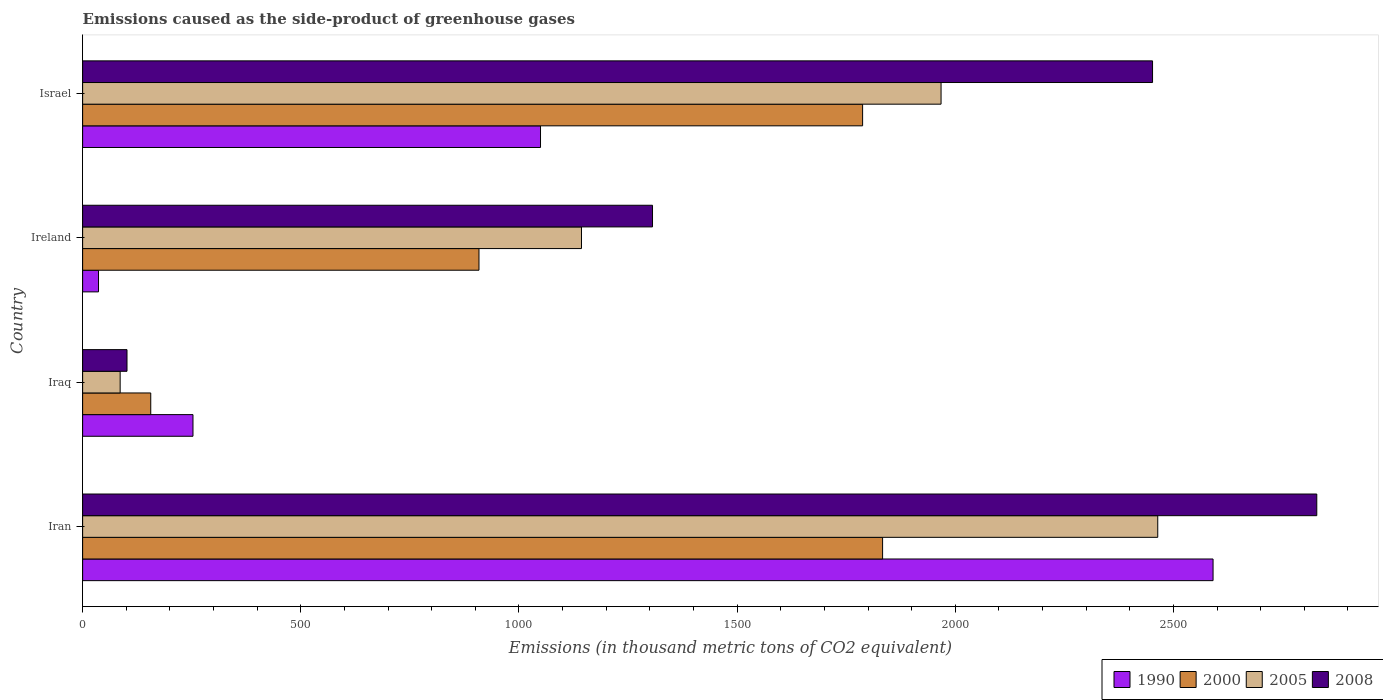How many groups of bars are there?
Your response must be concise. 4. How many bars are there on the 3rd tick from the top?
Make the answer very short. 4. How many bars are there on the 2nd tick from the bottom?
Your answer should be compact. 4. What is the label of the 2nd group of bars from the top?
Offer a very short reply. Ireland. In how many cases, is the number of bars for a given country not equal to the number of legend labels?
Provide a succinct answer. 0. Across all countries, what is the maximum emissions caused as the side-product of greenhouse gases in 1990?
Make the answer very short. 2590.8. Across all countries, what is the minimum emissions caused as the side-product of greenhouse gases in 2008?
Give a very brief answer. 101.7. In which country was the emissions caused as the side-product of greenhouse gases in 1990 maximum?
Offer a terse response. Iran. In which country was the emissions caused as the side-product of greenhouse gases in 1990 minimum?
Your response must be concise. Ireland. What is the total emissions caused as the side-product of greenhouse gases in 1990 in the graph?
Provide a succinct answer. 3929.5. What is the difference between the emissions caused as the side-product of greenhouse gases in 2000 in Iran and that in Israel?
Provide a short and direct response. 45.8. What is the difference between the emissions caused as the side-product of greenhouse gases in 1990 in Ireland and the emissions caused as the side-product of greenhouse gases in 2000 in Israel?
Ensure brevity in your answer.  -1751.2. What is the average emissions caused as the side-product of greenhouse gases in 1990 per country?
Your response must be concise. 982.38. What is the difference between the emissions caused as the side-product of greenhouse gases in 2005 and emissions caused as the side-product of greenhouse gases in 1990 in Iran?
Your answer should be very brief. -126.8. What is the ratio of the emissions caused as the side-product of greenhouse gases in 2000 in Iran to that in Israel?
Your answer should be compact. 1.03. Is the emissions caused as the side-product of greenhouse gases in 2008 in Iran less than that in Ireland?
Provide a succinct answer. No. What is the difference between the highest and the second highest emissions caused as the side-product of greenhouse gases in 1990?
Offer a terse response. 1541.4. What is the difference between the highest and the lowest emissions caused as the side-product of greenhouse gases in 2008?
Offer a very short reply. 2726.8. What does the 4th bar from the top in Iraq represents?
Ensure brevity in your answer.  1990. What does the 2nd bar from the bottom in Ireland represents?
Ensure brevity in your answer.  2000. Is it the case that in every country, the sum of the emissions caused as the side-product of greenhouse gases in 2005 and emissions caused as the side-product of greenhouse gases in 2000 is greater than the emissions caused as the side-product of greenhouse gases in 1990?
Give a very brief answer. No. Are all the bars in the graph horizontal?
Give a very brief answer. Yes. What is the difference between two consecutive major ticks on the X-axis?
Give a very brief answer. 500. Are the values on the major ticks of X-axis written in scientific E-notation?
Offer a very short reply. No. How many legend labels are there?
Offer a very short reply. 4. How are the legend labels stacked?
Provide a succinct answer. Horizontal. What is the title of the graph?
Keep it short and to the point. Emissions caused as the side-product of greenhouse gases. What is the label or title of the X-axis?
Provide a succinct answer. Emissions (in thousand metric tons of CO2 equivalent). What is the Emissions (in thousand metric tons of CO2 equivalent) in 1990 in Iran?
Make the answer very short. 2590.8. What is the Emissions (in thousand metric tons of CO2 equivalent) in 2000 in Iran?
Ensure brevity in your answer.  1833.4. What is the Emissions (in thousand metric tons of CO2 equivalent) in 2005 in Iran?
Provide a short and direct response. 2464. What is the Emissions (in thousand metric tons of CO2 equivalent) of 2008 in Iran?
Provide a succinct answer. 2828.5. What is the Emissions (in thousand metric tons of CO2 equivalent) of 1990 in Iraq?
Your answer should be compact. 252.9. What is the Emissions (in thousand metric tons of CO2 equivalent) in 2000 in Iraq?
Keep it short and to the point. 156.1. What is the Emissions (in thousand metric tons of CO2 equivalent) in 2008 in Iraq?
Ensure brevity in your answer.  101.7. What is the Emissions (in thousand metric tons of CO2 equivalent) of 1990 in Ireland?
Your response must be concise. 36.4. What is the Emissions (in thousand metric tons of CO2 equivalent) of 2000 in Ireland?
Ensure brevity in your answer.  908.4. What is the Emissions (in thousand metric tons of CO2 equivalent) in 2005 in Ireland?
Provide a succinct answer. 1143.3. What is the Emissions (in thousand metric tons of CO2 equivalent) in 2008 in Ireland?
Offer a very short reply. 1306.1. What is the Emissions (in thousand metric tons of CO2 equivalent) of 1990 in Israel?
Offer a terse response. 1049.4. What is the Emissions (in thousand metric tons of CO2 equivalent) of 2000 in Israel?
Offer a terse response. 1787.6. What is the Emissions (in thousand metric tons of CO2 equivalent) in 2005 in Israel?
Provide a succinct answer. 1967.4. What is the Emissions (in thousand metric tons of CO2 equivalent) in 2008 in Israel?
Provide a succinct answer. 2452.1. Across all countries, what is the maximum Emissions (in thousand metric tons of CO2 equivalent) of 1990?
Offer a very short reply. 2590.8. Across all countries, what is the maximum Emissions (in thousand metric tons of CO2 equivalent) in 2000?
Give a very brief answer. 1833.4. Across all countries, what is the maximum Emissions (in thousand metric tons of CO2 equivalent) of 2005?
Provide a short and direct response. 2464. Across all countries, what is the maximum Emissions (in thousand metric tons of CO2 equivalent) in 2008?
Ensure brevity in your answer.  2828.5. Across all countries, what is the minimum Emissions (in thousand metric tons of CO2 equivalent) in 1990?
Give a very brief answer. 36.4. Across all countries, what is the minimum Emissions (in thousand metric tons of CO2 equivalent) of 2000?
Offer a terse response. 156.1. Across all countries, what is the minimum Emissions (in thousand metric tons of CO2 equivalent) in 2008?
Ensure brevity in your answer.  101.7. What is the total Emissions (in thousand metric tons of CO2 equivalent) of 1990 in the graph?
Offer a very short reply. 3929.5. What is the total Emissions (in thousand metric tons of CO2 equivalent) of 2000 in the graph?
Provide a short and direct response. 4685.5. What is the total Emissions (in thousand metric tons of CO2 equivalent) of 2005 in the graph?
Offer a terse response. 5660.7. What is the total Emissions (in thousand metric tons of CO2 equivalent) of 2008 in the graph?
Give a very brief answer. 6688.4. What is the difference between the Emissions (in thousand metric tons of CO2 equivalent) of 1990 in Iran and that in Iraq?
Offer a very short reply. 2337.9. What is the difference between the Emissions (in thousand metric tons of CO2 equivalent) of 2000 in Iran and that in Iraq?
Keep it short and to the point. 1677.3. What is the difference between the Emissions (in thousand metric tons of CO2 equivalent) in 2005 in Iran and that in Iraq?
Your answer should be compact. 2378. What is the difference between the Emissions (in thousand metric tons of CO2 equivalent) in 2008 in Iran and that in Iraq?
Offer a very short reply. 2726.8. What is the difference between the Emissions (in thousand metric tons of CO2 equivalent) of 1990 in Iran and that in Ireland?
Offer a terse response. 2554.4. What is the difference between the Emissions (in thousand metric tons of CO2 equivalent) of 2000 in Iran and that in Ireland?
Give a very brief answer. 925. What is the difference between the Emissions (in thousand metric tons of CO2 equivalent) of 2005 in Iran and that in Ireland?
Make the answer very short. 1320.7. What is the difference between the Emissions (in thousand metric tons of CO2 equivalent) of 2008 in Iran and that in Ireland?
Your answer should be very brief. 1522.4. What is the difference between the Emissions (in thousand metric tons of CO2 equivalent) in 1990 in Iran and that in Israel?
Keep it short and to the point. 1541.4. What is the difference between the Emissions (in thousand metric tons of CO2 equivalent) of 2000 in Iran and that in Israel?
Make the answer very short. 45.8. What is the difference between the Emissions (in thousand metric tons of CO2 equivalent) of 2005 in Iran and that in Israel?
Provide a short and direct response. 496.6. What is the difference between the Emissions (in thousand metric tons of CO2 equivalent) of 2008 in Iran and that in Israel?
Ensure brevity in your answer.  376.4. What is the difference between the Emissions (in thousand metric tons of CO2 equivalent) in 1990 in Iraq and that in Ireland?
Your answer should be very brief. 216.5. What is the difference between the Emissions (in thousand metric tons of CO2 equivalent) in 2000 in Iraq and that in Ireland?
Your answer should be compact. -752.3. What is the difference between the Emissions (in thousand metric tons of CO2 equivalent) in 2005 in Iraq and that in Ireland?
Offer a terse response. -1057.3. What is the difference between the Emissions (in thousand metric tons of CO2 equivalent) in 2008 in Iraq and that in Ireland?
Offer a very short reply. -1204.4. What is the difference between the Emissions (in thousand metric tons of CO2 equivalent) in 1990 in Iraq and that in Israel?
Keep it short and to the point. -796.5. What is the difference between the Emissions (in thousand metric tons of CO2 equivalent) in 2000 in Iraq and that in Israel?
Keep it short and to the point. -1631.5. What is the difference between the Emissions (in thousand metric tons of CO2 equivalent) in 2005 in Iraq and that in Israel?
Your answer should be compact. -1881.4. What is the difference between the Emissions (in thousand metric tons of CO2 equivalent) of 2008 in Iraq and that in Israel?
Ensure brevity in your answer.  -2350.4. What is the difference between the Emissions (in thousand metric tons of CO2 equivalent) of 1990 in Ireland and that in Israel?
Give a very brief answer. -1013. What is the difference between the Emissions (in thousand metric tons of CO2 equivalent) in 2000 in Ireland and that in Israel?
Your answer should be very brief. -879.2. What is the difference between the Emissions (in thousand metric tons of CO2 equivalent) in 2005 in Ireland and that in Israel?
Make the answer very short. -824.1. What is the difference between the Emissions (in thousand metric tons of CO2 equivalent) in 2008 in Ireland and that in Israel?
Give a very brief answer. -1146. What is the difference between the Emissions (in thousand metric tons of CO2 equivalent) in 1990 in Iran and the Emissions (in thousand metric tons of CO2 equivalent) in 2000 in Iraq?
Offer a very short reply. 2434.7. What is the difference between the Emissions (in thousand metric tons of CO2 equivalent) in 1990 in Iran and the Emissions (in thousand metric tons of CO2 equivalent) in 2005 in Iraq?
Provide a short and direct response. 2504.8. What is the difference between the Emissions (in thousand metric tons of CO2 equivalent) in 1990 in Iran and the Emissions (in thousand metric tons of CO2 equivalent) in 2008 in Iraq?
Your response must be concise. 2489.1. What is the difference between the Emissions (in thousand metric tons of CO2 equivalent) in 2000 in Iran and the Emissions (in thousand metric tons of CO2 equivalent) in 2005 in Iraq?
Keep it short and to the point. 1747.4. What is the difference between the Emissions (in thousand metric tons of CO2 equivalent) in 2000 in Iran and the Emissions (in thousand metric tons of CO2 equivalent) in 2008 in Iraq?
Provide a short and direct response. 1731.7. What is the difference between the Emissions (in thousand metric tons of CO2 equivalent) of 2005 in Iran and the Emissions (in thousand metric tons of CO2 equivalent) of 2008 in Iraq?
Offer a terse response. 2362.3. What is the difference between the Emissions (in thousand metric tons of CO2 equivalent) in 1990 in Iran and the Emissions (in thousand metric tons of CO2 equivalent) in 2000 in Ireland?
Keep it short and to the point. 1682.4. What is the difference between the Emissions (in thousand metric tons of CO2 equivalent) of 1990 in Iran and the Emissions (in thousand metric tons of CO2 equivalent) of 2005 in Ireland?
Offer a terse response. 1447.5. What is the difference between the Emissions (in thousand metric tons of CO2 equivalent) of 1990 in Iran and the Emissions (in thousand metric tons of CO2 equivalent) of 2008 in Ireland?
Provide a succinct answer. 1284.7. What is the difference between the Emissions (in thousand metric tons of CO2 equivalent) in 2000 in Iran and the Emissions (in thousand metric tons of CO2 equivalent) in 2005 in Ireland?
Make the answer very short. 690.1. What is the difference between the Emissions (in thousand metric tons of CO2 equivalent) in 2000 in Iran and the Emissions (in thousand metric tons of CO2 equivalent) in 2008 in Ireland?
Provide a short and direct response. 527.3. What is the difference between the Emissions (in thousand metric tons of CO2 equivalent) of 2005 in Iran and the Emissions (in thousand metric tons of CO2 equivalent) of 2008 in Ireland?
Your answer should be very brief. 1157.9. What is the difference between the Emissions (in thousand metric tons of CO2 equivalent) in 1990 in Iran and the Emissions (in thousand metric tons of CO2 equivalent) in 2000 in Israel?
Your answer should be compact. 803.2. What is the difference between the Emissions (in thousand metric tons of CO2 equivalent) in 1990 in Iran and the Emissions (in thousand metric tons of CO2 equivalent) in 2005 in Israel?
Your answer should be very brief. 623.4. What is the difference between the Emissions (in thousand metric tons of CO2 equivalent) in 1990 in Iran and the Emissions (in thousand metric tons of CO2 equivalent) in 2008 in Israel?
Ensure brevity in your answer.  138.7. What is the difference between the Emissions (in thousand metric tons of CO2 equivalent) of 2000 in Iran and the Emissions (in thousand metric tons of CO2 equivalent) of 2005 in Israel?
Offer a very short reply. -134. What is the difference between the Emissions (in thousand metric tons of CO2 equivalent) in 2000 in Iran and the Emissions (in thousand metric tons of CO2 equivalent) in 2008 in Israel?
Provide a short and direct response. -618.7. What is the difference between the Emissions (in thousand metric tons of CO2 equivalent) of 2005 in Iran and the Emissions (in thousand metric tons of CO2 equivalent) of 2008 in Israel?
Offer a terse response. 11.9. What is the difference between the Emissions (in thousand metric tons of CO2 equivalent) in 1990 in Iraq and the Emissions (in thousand metric tons of CO2 equivalent) in 2000 in Ireland?
Give a very brief answer. -655.5. What is the difference between the Emissions (in thousand metric tons of CO2 equivalent) in 1990 in Iraq and the Emissions (in thousand metric tons of CO2 equivalent) in 2005 in Ireland?
Your answer should be very brief. -890.4. What is the difference between the Emissions (in thousand metric tons of CO2 equivalent) of 1990 in Iraq and the Emissions (in thousand metric tons of CO2 equivalent) of 2008 in Ireland?
Offer a terse response. -1053.2. What is the difference between the Emissions (in thousand metric tons of CO2 equivalent) of 2000 in Iraq and the Emissions (in thousand metric tons of CO2 equivalent) of 2005 in Ireland?
Keep it short and to the point. -987.2. What is the difference between the Emissions (in thousand metric tons of CO2 equivalent) in 2000 in Iraq and the Emissions (in thousand metric tons of CO2 equivalent) in 2008 in Ireland?
Your answer should be very brief. -1150. What is the difference between the Emissions (in thousand metric tons of CO2 equivalent) in 2005 in Iraq and the Emissions (in thousand metric tons of CO2 equivalent) in 2008 in Ireland?
Make the answer very short. -1220.1. What is the difference between the Emissions (in thousand metric tons of CO2 equivalent) in 1990 in Iraq and the Emissions (in thousand metric tons of CO2 equivalent) in 2000 in Israel?
Make the answer very short. -1534.7. What is the difference between the Emissions (in thousand metric tons of CO2 equivalent) of 1990 in Iraq and the Emissions (in thousand metric tons of CO2 equivalent) of 2005 in Israel?
Provide a short and direct response. -1714.5. What is the difference between the Emissions (in thousand metric tons of CO2 equivalent) of 1990 in Iraq and the Emissions (in thousand metric tons of CO2 equivalent) of 2008 in Israel?
Offer a terse response. -2199.2. What is the difference between the Emissions (in thousand metric tons of CO2 equivalent) of 2000 in Iraq and the Emissions (in thousand metric tons of CO2 equivalent) of 2005 in Israel?
Provide a short and direct response. -1811.3. What is the difference between the Emissions (in thousand metric tons of CO2 equivalent) of 2000 in Iraq and the Emissions (in thousand metric tons of CO2 equivalent) of 2008 in Israel?
Make the answer very short. -2296. What is the difference between the Emissions (in thousand metric tons of CO2 equivalent) of 2005 in Iraq and the Emissions (in thousand metric tons of CO2 equivalent) of 2008 in Israel?
Give a very brief answer. -2366.1. What is the difference between the Emissions (in thousand metric tons of CO2 equivalent) in 1990 in Ireland and the Emissions (in thousand metric tons of CO2 equivalent) in 2000 in Israel?
Ensure brevity in your answer.  -1751.2. What is the difference between the Emissions (in thousand metric tons of CO2 equivalent) of 1990 in Ireland and the Emissions (in thousand metric tons of CO2 equivalent) of 2005 in Israel?
Your answer should be very brief. -1931. What is the difference between the Emissions (in thousand metric tons of CO2 equivalent) of 1990 in Ireland and the Emissions (in thousand metric tons of CO2 equivalent) of 2008 in Israel?
Your answer should be compact. -2415.7. What is the difference between the Emissions (in thousand metric tons of CO2 equivalent) of 2000 in Ireland and the Emissions (in thousand metric tons of CO2 equivalent) of 2005 in Israel?
Offer a very short reply. -1059. What is the difference between the Emissions (in thousand metric tons of CO2 equivalent) of 2000 in Ireland and the Emissions (in thousand metric tons of CO2 equivalent) of 2008 in Israel?
Ensure brevity in your answer.  -1543.7. What is the difference between the Emissions (in thousand metric tons of CO2 equivalent) in 2005 in Ireland and the Emissions (in thousand metric tons of CO2 equivalent) in 2008 in Israel?
Make the answer very short. -1308.8. What is the average Emissions (in thousand metric tons of CO2 equivalent) of 1990 per country?
Offer a terse response. 982.38. What is the average Emissions (in thousand metric tons of CO2 equivalent) in 2000 per country?
Your response must be concise. 1171.38. What is the average Emissions (in thousand metric tons of CO2 equivalent) in 2005 per country?
Ensure brevity in your answer.  1415.17. What is the average Emissions (in thousand metric tons of CO2 equivalent) of 2008 per country?
Give a very brief answer. 1672.1. What is the difference between the Emissions (in thousand metric tons of CO2 equivalent) in 1990 and Emissions (in thousand metric tons of CO2 equivalent) in 2000 in Iran?
Provide a short and direct response. 757.4. What is the difference between the Emissions (in thousand metric tons of CO2 equivalent) in 1990 and Emissions (in thousand metric tons of CO2 equivalent) in 2005 in Iran?
Give a very brief answer. 126.8. What is the difference between the Emissions (in thousand metric tons of CO2 equivalent) in 1990 and Emissions (in thousand metric tons of CO2 equivalent) in 2008 in Iran?
Offer a very short reply. -237.7. What is the difference between the Emissions (in thousand metric tons of CO2 equivalent) in 2000 and Emissions (in thousand metric tons of CO2 equivalent) in 2005 in Iran?
Your answer should be compact. -630.6. What is the difference between the Emissions (in thousand metric tons of CO2 equivalent) in 2000 and Emissions (in thousand metric tons of CO2 equivalent) in 2008 in Iran?
Offer a terse response. -995.1. What is the difference between the Emissions (in thousand metric tons of CO2 equivalent) of 2005 and Emissions (in thousand metric tons of CO2 equivalent) of 2008 in Iran?
Offer a very short reply. -364.5. What is the difference between the Emissions (in thousand metric tons of CO2 equivalent) in 1990 and Emissions (in thousand metric tons of CO2 equivalent) in 2000 in Iraq?
Your response must be concise. 96.8. What is the difference between the Emissions (in thousand metric tons of CO2 equivalent) of 1990 and Emissions (in thousand metric tons of CO2 equivalent) of 2005 in Iraq?
Your answer should be very brief. 166.9. What is the difference between the Emissions (in thousand metric tons of CO2 equivalent) of 1990 and Emissions (in thousand metric tons of CO2 equivalent) of 2008 in Iraq?
Provide a succinct answer. 151.2. What is the difference between the Emissions (in thousand metric tons of CO2 equivalent) of 2000 and Emissions (in thousand metric tons of CO2 equivalent) of 2005 in Iraq?
Your answer should be very brief. 70.1. What is the difference between the Emissions (in thousand metric tons of CO2 equivalent) of 2000 and Emissions (in thousand metric tons of CO2 equivalent) of 2008 in Iraq?
Offer a very short reply. 54.4. What is the difference between the Emissions (in thousand metric tons of CO2 equivalent) of 2005 and Emissions (in thousand metric tons of CO2 equivalent) of 2008 in Iraq?
Give a very brief answer. -15.7. What is the difference between the Emissions (in thousand metric tons of CO2 equivalent) of 1990 and Emissions (in thousand metric tons of CO2 equivalent) of 2000 in Ireland?
Offer a terse response. -872. What is the difference between the Emissions (in thousand metric tons of CO2 equivalent) in 1990 and Emissions (in thousand metric tons of CO2 equivalent) in 2005 in Ireland?
Provide a succinct answer. -1106.9. What is the difference between the Emissions (in thousand metric tons of CO2 equivalent) of 1990 and Emissions (in thousand metric tons of CO2 equivalent) of 2008 in Ireland?
Offer a very short reply. -1269.7. What is the difference between the Emissions (in thousand metric tons of CO2 equivalent) of 2000 and Emissions (in thousand metric tons of CO2 equivalent) of 2005 in Ireland?
Provide a succinct answer. -234.9. What is the difference between the Emissions (in thousand metric tons of CO2 equivalent) in 2000 and Emissions (in thousand metric tons of CO2 equivalent) in 2008 in Ireland?
Give a very brief answer. -397.7. What is the difference between the Emissions (in thousand metric tons of CO2 equivalent) in 2005 and Emissions (in thousand metric tons of CO2 equivalent) in 2008 in Ireland?
Offer a very short reply. -162.8. What is the difference between the Emissions (in thousand metric tons of CO2 equivalent) in 1990 and Emissions (in thousand metric tons of CO2 equivalent) in 2000 in Israel?
Provide a short and direct response. -738.2. What is the difference between the Emissions (in thousand metric tons of CO2 equivalent) in 1990 and Emissions (in thousand metric tons of CO2 equivalent) in 2005 in Israel?
Ensure brevity in your answer.  -918. What is the difference between the Emissions (in thousand metric tons of CO2 equivalent) of 1990 and Emissions (in thousand metric tons of CO2 equivalent) of 2008 in Israel?
Your answer should be very brief. -1402.7. What is the difference between the Emissions (in thousand metric tons of CO2 equivalent) in 2000 and Emissions (in thousand metric tons of CO2 equivalent) in 2005 in Israel?
Ensure brevity in your answer.  -179.8. What is the difference between the Emissions (in thousand metric tons of CO2 equivalent) in 2000 and Emissions (in thousand metric tons of CO2 equivalent) in 2008 in Israel?
Provide a short and direct response. -664.5. What is the difference between the Emissions (in thousand metric tons of CO2 equivalent) of 2005 and Emissions (in thousand metric tons of CO2 equivalent) of 2008 in Israel?
Your answer should be compact. -484.7. What is the ratio of the Emissions (in thousand metric tons of CO2 equivalent) of 1990 in Iran to that in Iraq?
Your answer should be very brief. 10.24. What is the ratio of the Emissions (in thousand metric tons of CO2 equivalent) in 2000 in Iran to that in Iraq?
Ensure brevity in your answer.  11.74. What is the ratio of the Emissions (in thousand metric tons of CO2 equivalent) of 2005 in Iran to that in Iraq?
Provide a short and direct response. 28.65. What is the ratio of the Emissions (in thousand metric tons of CO2 equivalent) of 2008 in Iran to that in Iraq?
Offer a very short reply. 27.81. What is the ratio of the Emissions (in thousand metric tons of CO2 equivalent) in 1990 in Iran to that in Ireland?
Give a very brief answer. 71.18. What is the ratio of the Emissions (in thousand metric tons of CO2 equivalent) in 2000 in Iran to that in Ireland?
Provide a succinct answer. 2.02. What is the ratio of the Emissions (in thousand metric tons of CO2 equivalent) in 2005 in Iran to that in Ireland?
Offer a terse response. 2.16. What is the ratio of the Emissions (in thousand metric tons of CO2 equivalent) in 2008 in Iran to that in Ireland?
Provide a short and direct response. 2.17. What is the ratio of the Emissions (in thousand metric tons of CO2 equivalent) in 1990 in Iran to that in Israel?
Give a very brief answer. 2.47. What is the ratio of the Emissions (in thousand metric tons of CO2 equivalent) of 2000 in Iran to that in Israel?
Give a very brief answer. 1.03. What is the ratio of the Emissions (in thousand metric tons of CO2 equivalent) in 2005 in Iran to that in Israel?
Give a very brief answer. 1.25. What is the ratio of the Emissions (in thousand metric tons of CO2 equivalent) in 2008 in Iran to that in Israel?
Make the answer very short. 1.15. What is the ratio of the Emissions (in thousand metric tons of CO2 equivalent) of 1990 in Iraq to that in Ireland?
Your answer should be very brief. 6.95. What is the ratio of the Emissions (in thousand metric tons of CO2 equivalent) in 2000 in Iraq to that in Ireland?
Make the answer very short. 0.17. What is the ratio of the Emissions (in thousand metric tons of CO2 equivalent) in 2005 in Iraq to that in Ireland?
Ensure brevity in your answer.  0.08. What is the ratio of the Emissions (in thousand metric tons of CO2 equivalent) of 2008 in Iraq to that in Ireland?
Offer a terse response. 0.08. What is the ratio of the Emissions (in thousand metric tons of CO2 equivalent) in 1990 in Iraq to that in Israel?
Your answer should be very brief. 0.24. What is the ratio of the Emissions (in thousand metric tons of CO2 equivalent) of 2000 in Iraq to that in Israel?
Your response must be concise. 0.09. What is the ratio of the Emissions (in thousand metric tons of CO2 equivalent) of 2005 in Iraq to that in Israel?
Offer a very short reply. 0.04. What is the ratio of the Emissions (in thousand metric tons of CO2 equivalent) in 2008 in Iraq to that in Israel?
Provide a short and direct response. 0.04. What is the ratio of the Emissions (in thousand metric tons of CO2 equivalent) of 1990 in Ireland to that in Israel?
Ensure brevity in your answer.  0.03. What is the ratio of the Emissions (in thousand metric tons of CO2 equivalent) of 2000 in Ireland to that in Israel?
Offer a very short reply. 0.51. What is the ratio of the Emissions (in thousand metric tons of CO2 equivalent) in 2005 in Ireland to that in Israel?
Provide a succinct answer. 0.58. What is the ratio of the Emissions (in thousand metric tons of CO2 equivalent) in 2008 in Ireland to that in Israel?
Keep it short and to the point. 0.53. What is the difference between the highest and the second highest Emissions (in thousand metric tons of CO2 equivalent) in 1990?
Provide a short and direct response. 1541.4. What is the difference between the highest and the second highest Emissions (in thousand metric tons of CO2 equivalent) in 2000?
Your answer should be very brief. 45.8. What is the difference between the highest and the second highest Emissions (in thousand metric tons of CO2 equivalent) in 2005?
Offer a terse response. 496.6. What is the difference between the highest and the second highest Emissions (in thousand metric tons of CO2 equivalent) of 2008?
Provide a succinct answer. 376.4. What is the difference between the highest and the lowest Emissions (in thousand metric tons of CO2 equivalent) of 1990?
Your answer should be compact. 2554.4. What is the difference between the highest and the lowest Emissions (in thousand metric tons of CO2 equivalent) of 2000?
Offer a very short reply. 1677.3. What is the difference between the highest and the lowest Emissions (in thousand metric tons of CO2 equivalent) of 2005?
Provide a short and direct response. 2378. What is the difference between the highest and the lowest Emissions (in thousand metric tons of CO2 equivalent) of 2008?
Offer a very short reply. 2726.8. 